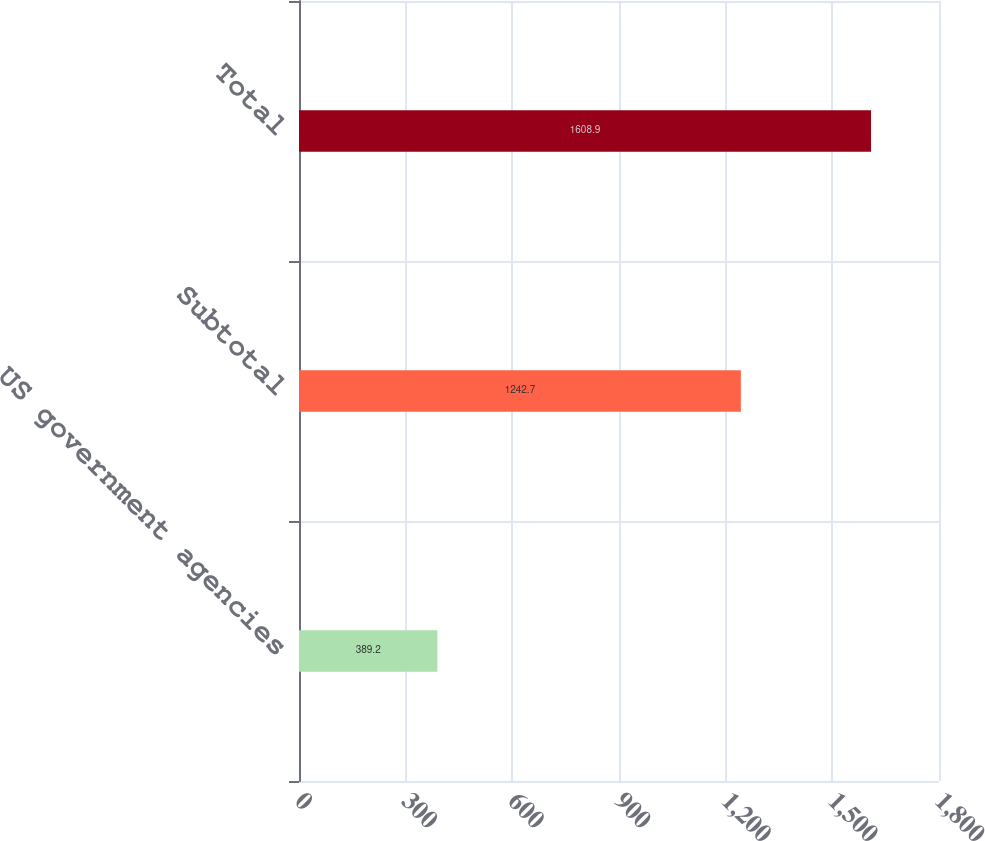<chart> <loc_0><loc_0><loc_500><loc_500><bar_chart><fcel>US government agencies<fcel>Subtotal<fcel>Total<nl><fcel>389.2<fcel>1242.7<fcel>1608.9<nl></chart> 